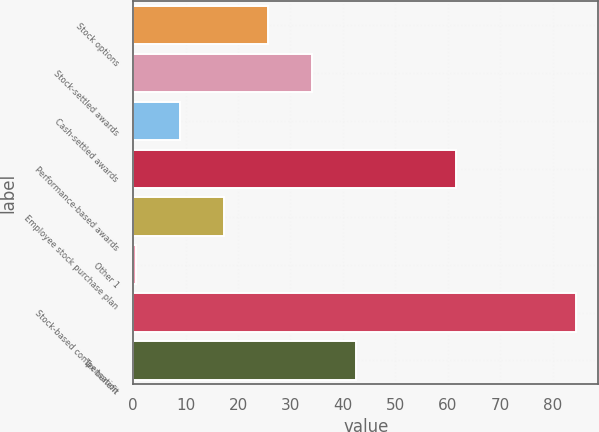Convert chart to OTSL. <chart><loc_0><loc_0><loc_500><loc_500><bar_chart><fcel>Stock options<fcel>Stock-settled awards<fcel>Cash-settled awards<fcel>Performance-based awards<fcel>Employee stock purchase plan<fcel>Other 1<fcel>Stock-based compensation<fcel>Tax benefit<nl><fcel>25.7<fcel>34.1<fcel>8.9<fcel>61.5<fcel>17.3<fcel>0.5<fcel>84.5<fcel>42.5<nl></chart> 